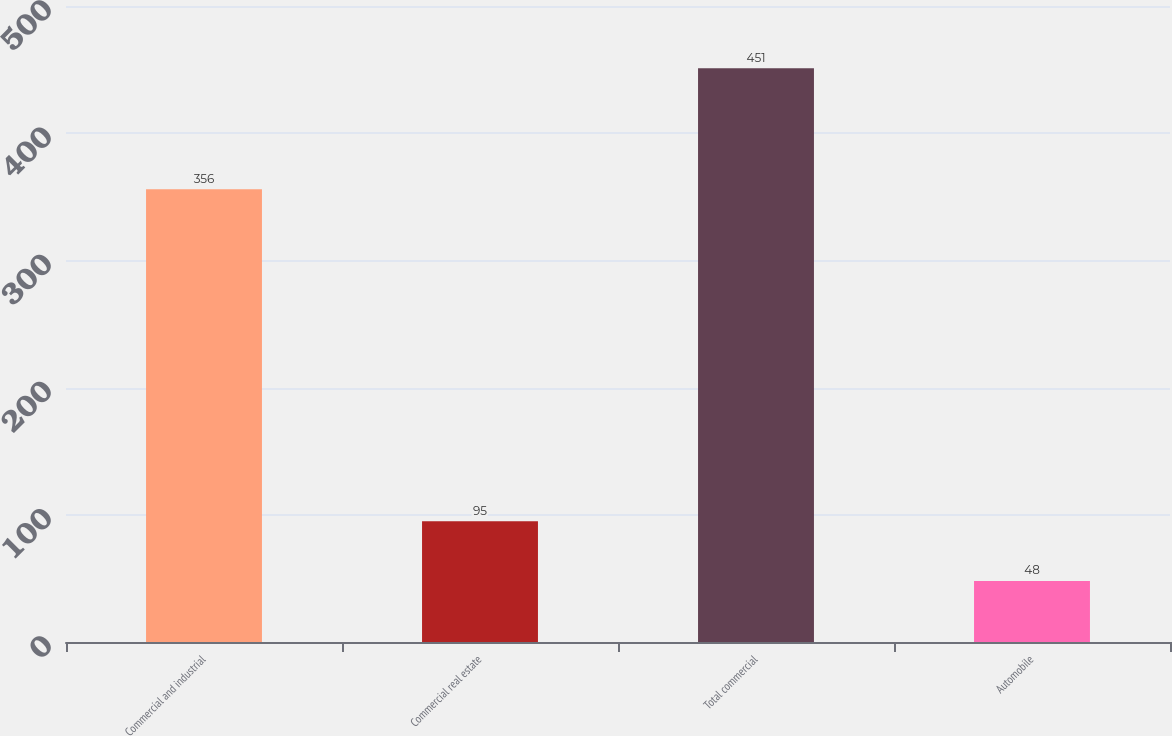<chart> <loc_0><loc_0><loc_500><loc_500><bar_chart><fcel>Commercial and industrial<fcel>Commercial real estate<fcel>Total commercial<fcel>Automobile<nl><fcel>356<fcel>95<fcel>451<fcel>48<nl></chart> 